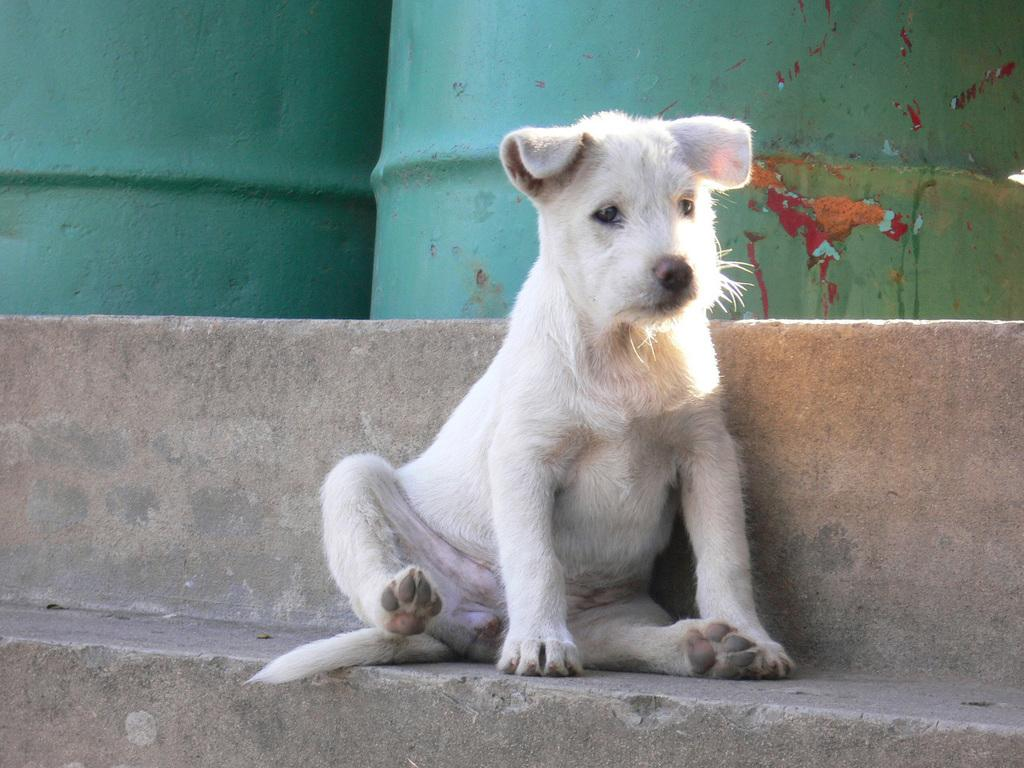What animal can be seen in the image? There is a dog in the image. Where is the dog located in the image? The dog is sitting on a step. What can be seen in the background of the image? There are barrels in the background of the image. What type of rod is the dog using to catch fish in the image? There is no rod or fishing activity present in the image; the dog is simply sitting on a step. 